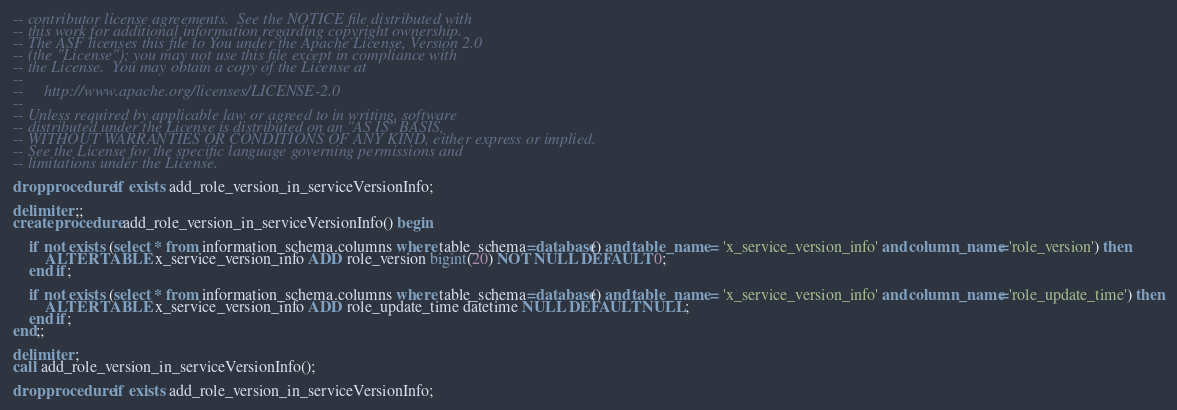<code> <loc_0><loc_0><loc_500><loc_500><_SQL_>-- contributor license agreements.  See the NOTICE file distributed with
-- this work for additional information regarding copyright ownership.
-- The ASF licenses this file to You under the Apache License, Version 2.0
-- (the "License"); you may not use this file except in compliance with
-- the License.  You may obtain a copy of the License at
--
--     http://www.apache.org/licenses/LICENSE-2.0
--
-- Unless required by applicable law or agreed to in writing, software
-- distributed under the License is distributed on an "AS IS" BASIS,
-- WITHOUT WARRANTIES OR CONDITIONS OF ANY KIND, either express or implied.
-- See the License for the specific language governing permissions and
-- limitations under the License.

drop procedure if exists add_role_version_in_serviceVersionInfo;

delimiter ;;
create procedure add_role_version_in_serviceVersionInfo() begin

	if not exists (select * from information_schema.columns where table_schema=database() and table_name = 'x_service_version_info' and column_name='role_version') then
		ALTER TABLE x_service_version_info ADD role_version bigint(20) NOT NULL DEFAULT 0;
	end if;

	if not exists (select * from information_schema.columns where table_schema=database() and table_name = 'x_service_version_info' and column_name='role_update_time') then
		ALTER TABLE x_service_version_info ADD role_update_time datetime NULL DEFAULT NULL;
	end if;
end;;

delimiter ;
call add_role_version_in_serviceVersionInfo();

drop procedure if exists add_role_version_in_serviceVersionInfo;
</code> 